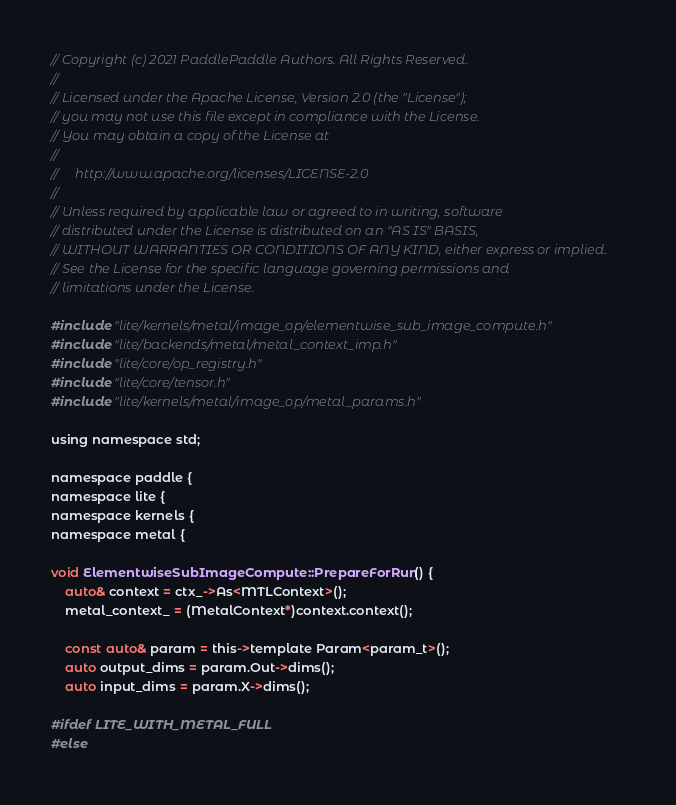<code> <loc_0><loc_0><loc_500><loc_500><_ObjectiveC_>// Copyright (c) 2021 PaddlePaddle Authors. All Rights Reserved.
//
// Licensed under the Apache License, Version 2.0 (the "License");
// you may not use this file except in compliance with the License.
// You may obtain a copy of the License at
//
//     http://www.apache.org/licenses/LICENSE-2.0
//
// Unless required by applicable law or agreed to in writing, software
// distributed under the License is distributed on an "AS IS" BASIS,
// WITHOUT WARRANTIES OR CONDITIONS OF ANY KIND, either express or implied.
// See the License for the specific language governing permissions and
// limitations under the License.

#include "lite/kernels/metal/image_op/elementwise_sub_image_compute.h"
#include "lite/backends/metal/metal_context_imp.h"
#include "lite/core/op_registry.h"
#include "lite/core/tensor.h"
#include "lite/kernels/metal/image_op/metal_params.h"

using namespace std;

namespace paddle {
namespace lite {
namespace kernels {
namespace metal {

void ElementwiseSubImageCompute::PrepareForRun() {
    auto& context = ctx_->As<MTLContext>();
    metal_context_ = (MetalContext*)context.context();

    const auto& param = this->template Param<param_t>();
    auto output_dims = param.Out->dims();
    auto input_dims = param.X->dims();

#ifdef LITE_WITH_METAL_FULL
#else</code> 